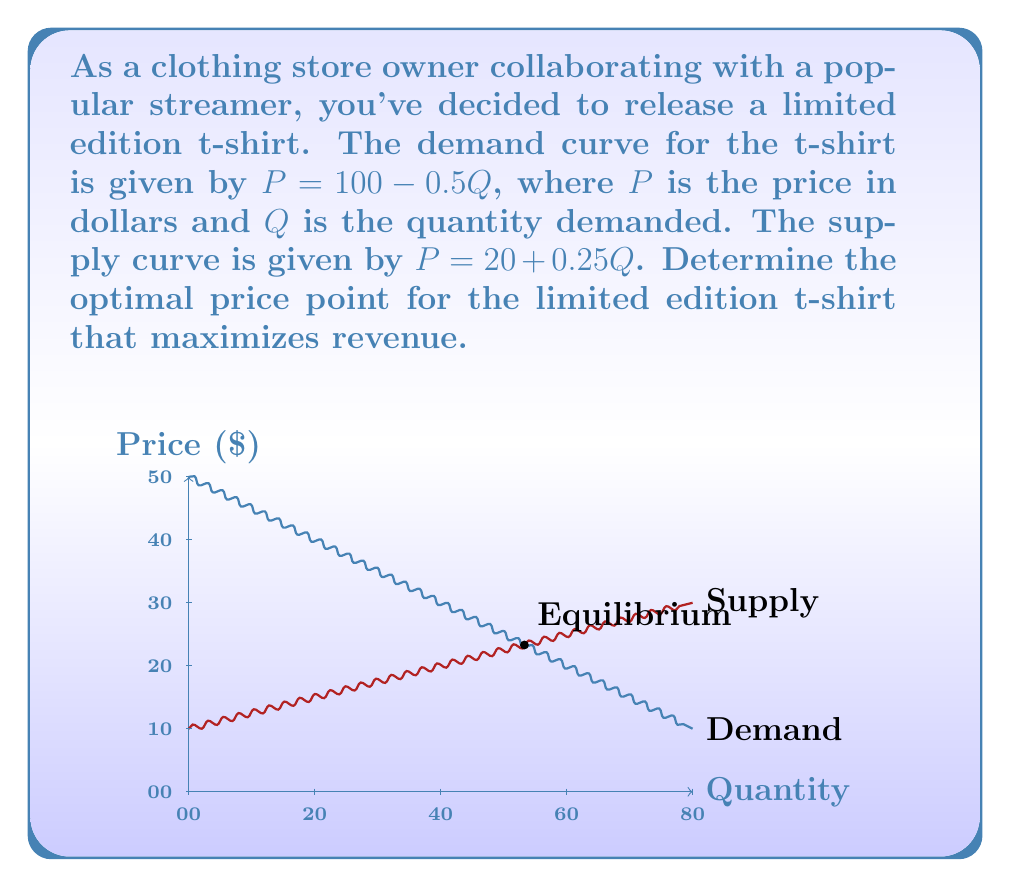Show me your answer to this math problem. To find the optimal price point that maximizes revenue, we need to follow these steps:

1) First, find the equilibrium point by equating demand and supply:
   $100 - 0.5Q = 20 + 0.25Q$
   $80 = 0.75Q$
   $Q = 106.67$

2) The equilibrium price is:
   $P = 100 - 0.5(106.67) = 46.67$

3) However, this equilibrium point doesn't necessarily maximize revenue. To find the revenue-maximizing point, we need to use the demand function and find where marginal revenue equals zero.

4) Revenue function: $R = PQ = (100 - 0.5Q)Q = 100Q - 0.5Q^2$

5) Marginal Revenue: $MR = \frac{dR}{dQ} = 100 - Q$

6) Set MR to zero and solve:
   $100 - Q = 0$
   $Q = 100$

7) Now, plug this quantity back into the demand equation to find the optimal price:
   $P = 100 - 0.5(100) = 50$

8) Therefore, the optimal price point is $50, and the corresponding quantity is 100.

9) We can verify that this maximizes revenue:
   $R = 50 * 100 = 5000$

   This is indeed greater than the revenue at the equilibrium point:
   $46.67 * 106.67 = 4978.44$
Answer: $50 